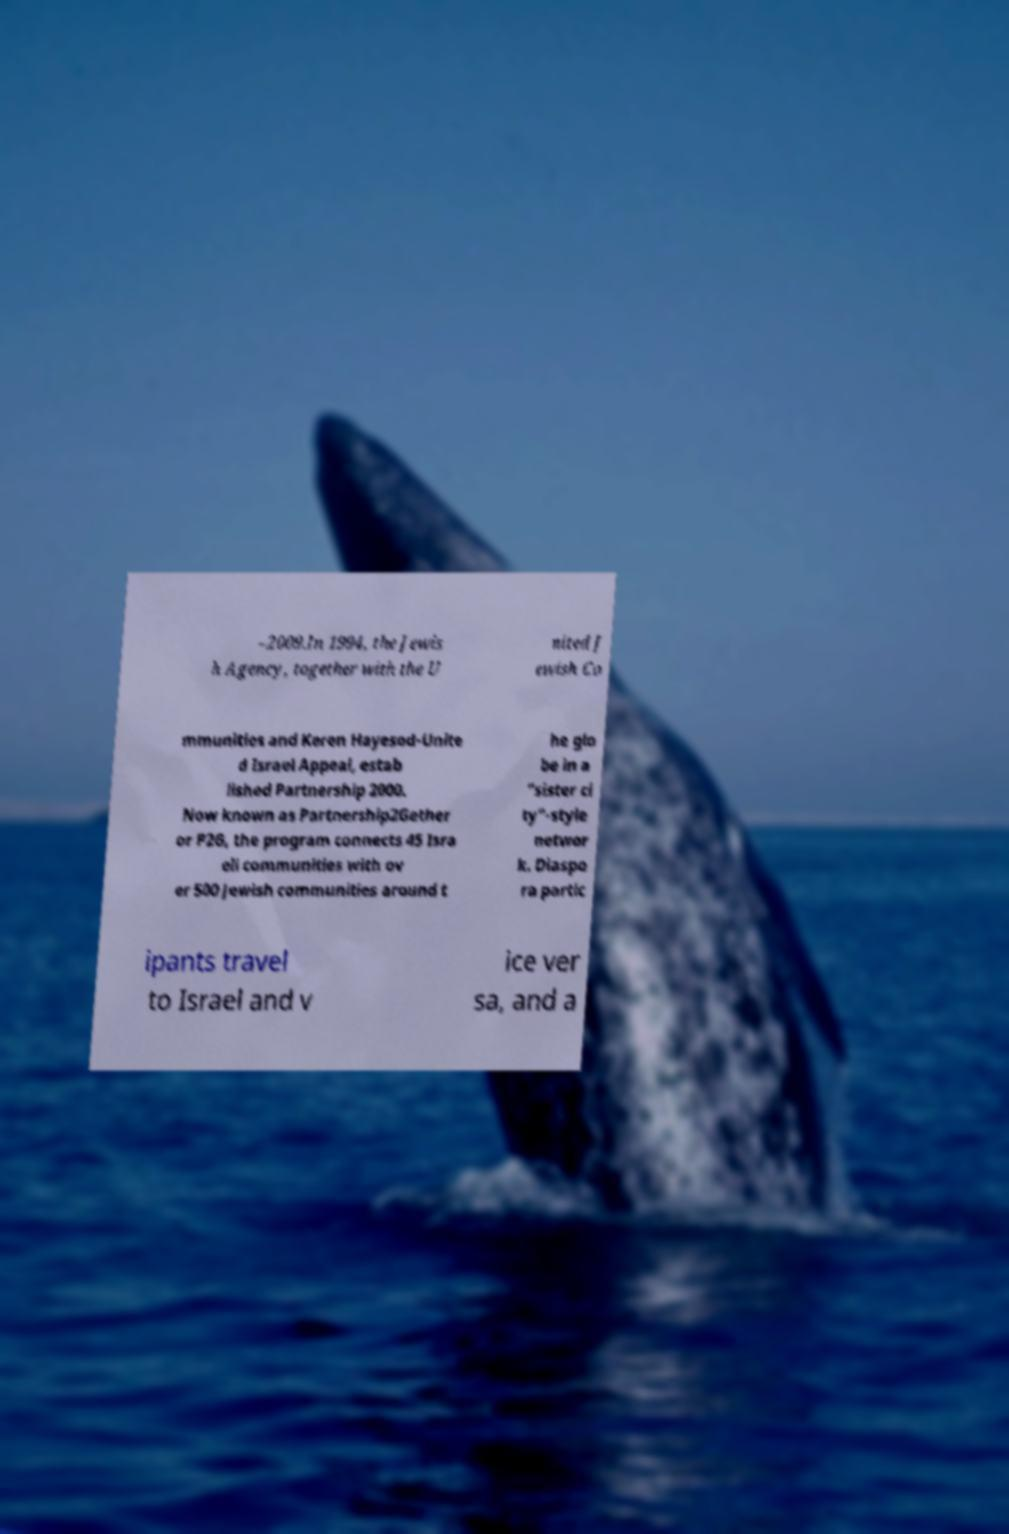Please read and relay the text visible in this image. What does it say? –2009.In 1994, the Jewis h Agency, together with the U nited J ewish Co mmunities and Keren Hayesod-Unite d Israel Appeal, estab lished Partnership 2000. Now known as Partnership2Gether or P2G, the program connects 45 Isra eli communities with ov er 500 Jewish communities around t he glo be in a "sister ci ty"-style networ k. Diaspo ra partic ipants travel to Israel and v ice ver sa, and a 